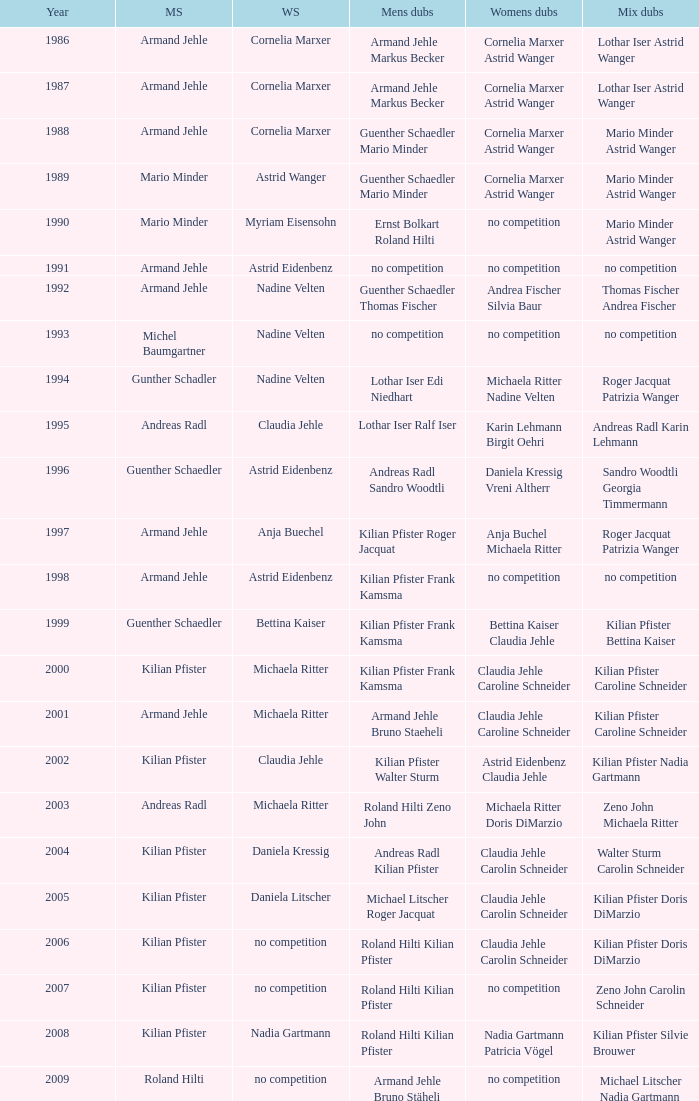In 2004, where the womens singles is daniela kressig who is the mens singles Kilian Pfister. 